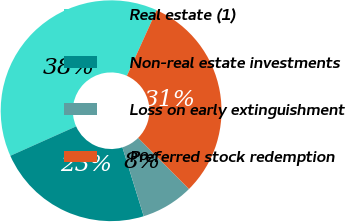<chart> <loc_0><loc_0><loc_500><loc_500><pie_chart><fcel>Real estate (1)<fcel>Non-real estate investments<fcel>Loss on early extinguishment<fcel>Preferred stock redemption<nl><fcel>38.46%<fcel>23.08%<fcel>7.69%<fcel>30.77%<nl></chart> 